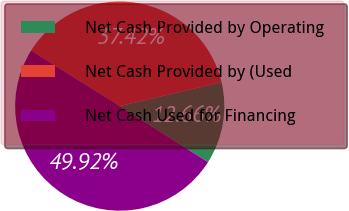Convert chart to OTSL. <chart><loc_0><loc_0><loc_500><loc_500><pie_chart><fcel>Net Cash Provided by Operating<fcel>Net Cash Provided by (Used<fcel>Net Cash Used for Financing<nl><fcel>12.66%<fcel>37.42%<fcel>49.92%<nl></chart> 